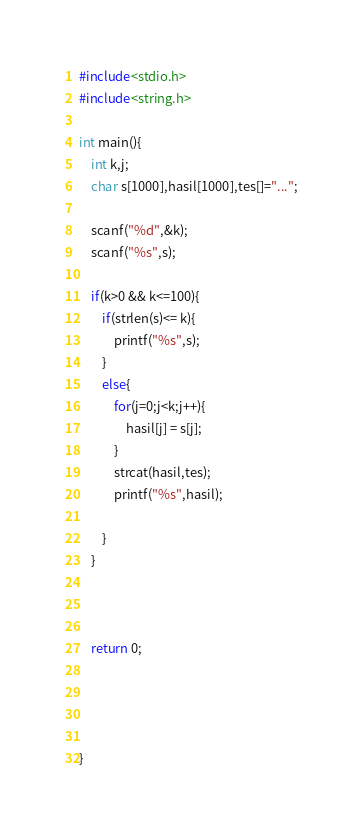Convert code to text. <code><loc_0><loc_0><loc_500><loc_500><_C_>#include<stdio.h>
#include<string.h>

int main(){
	int k,j;
	char s[1000],hasil[1000],tes[]="...";
	
	scanf("%d",&k);
	scanf("%s",s);
	
	if(k>0 && k<=100){
		if(strlen(s)<= k){
			printf("%s",s);
		}
		else{
			for(j=0;j<k;j++){
				hasil[j] = s[j];
			}
			strcat(hasil,tes);
			printf("%s",hasil);
		
		}	
	}
	
	
	
	return 0;
	
  
 
  
}
</code> 